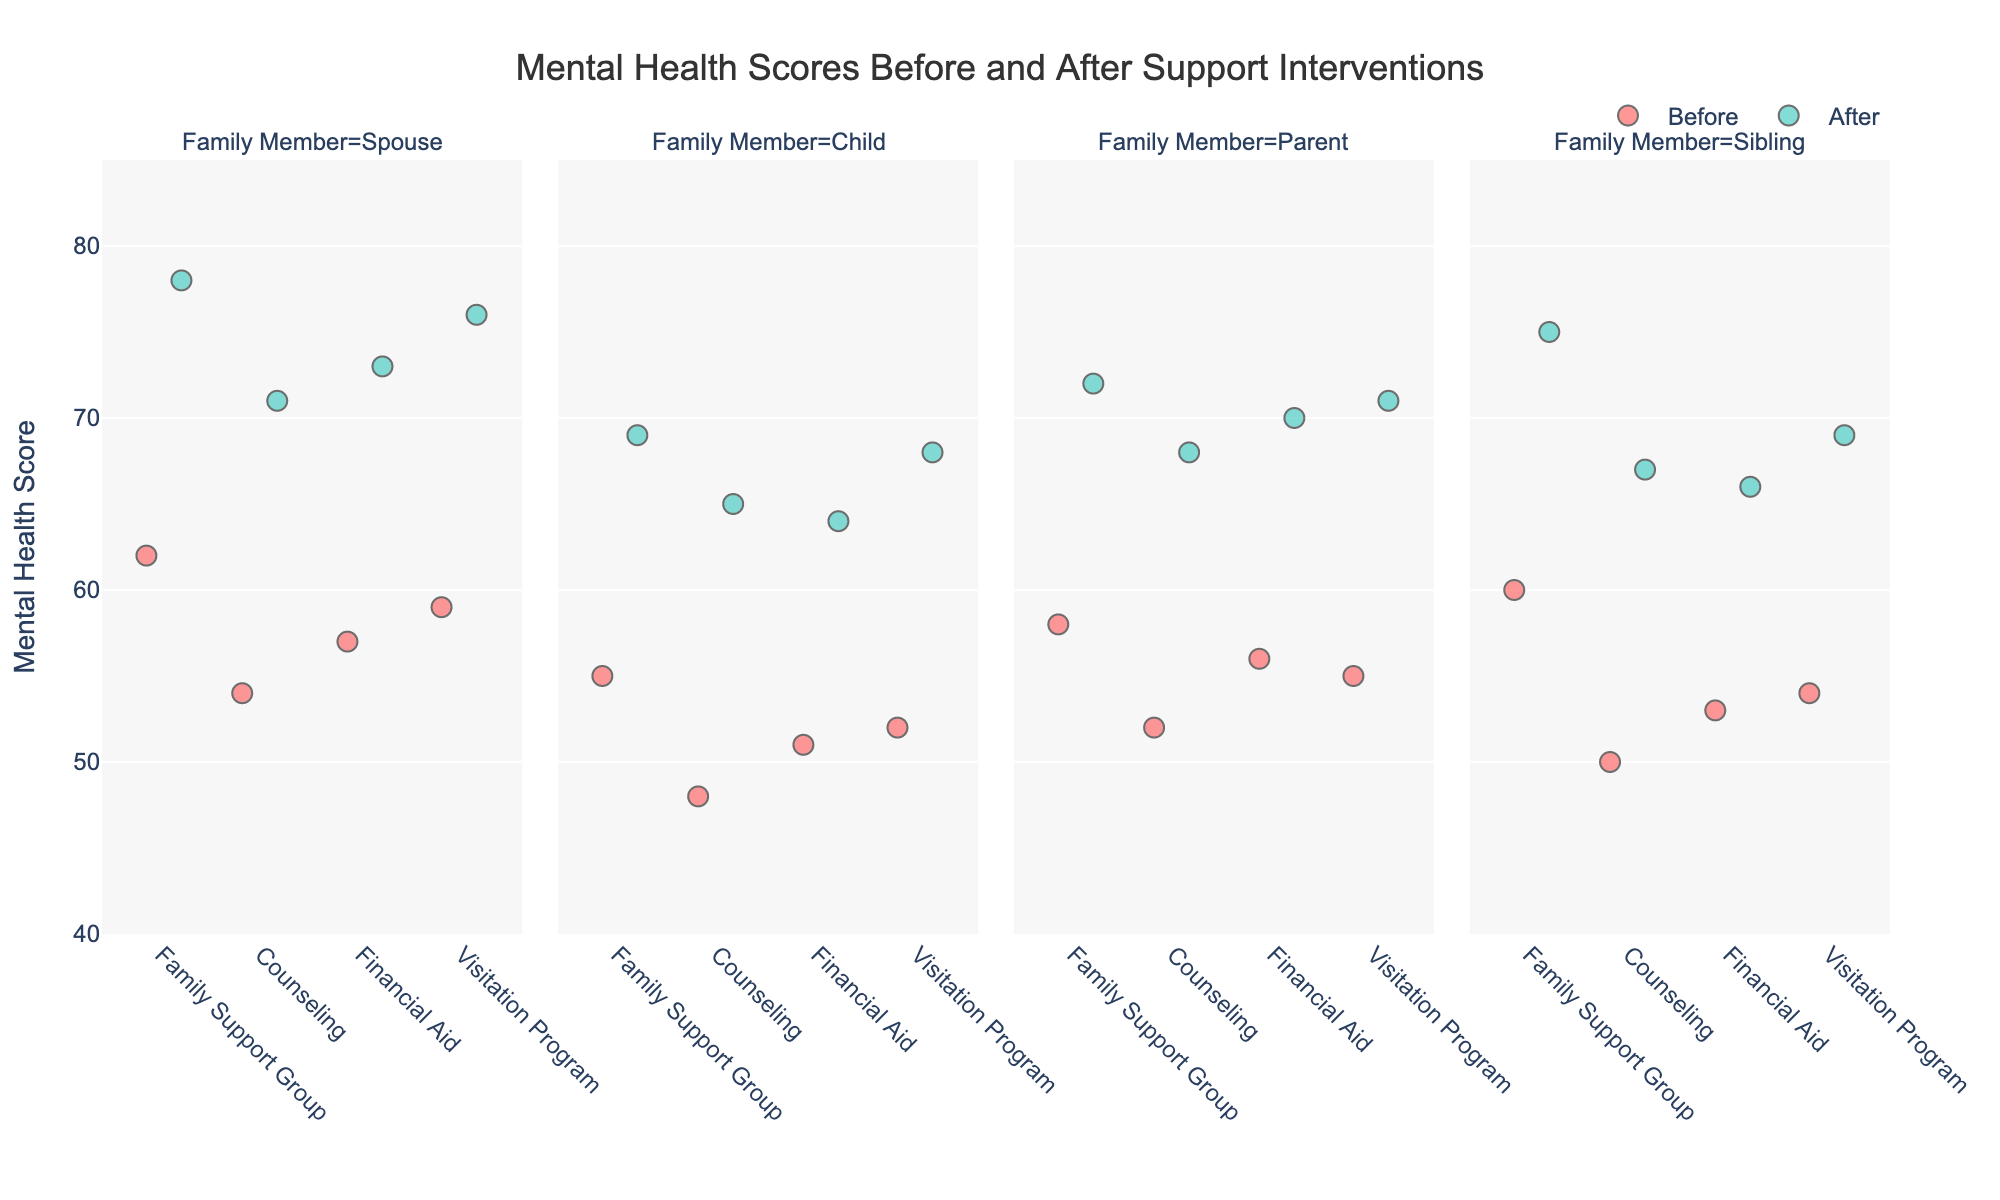What is the title of the figure? The title is found at the top center of the figure and provides a summary of what the figure represents.
Answer: Mental Health Scores Before and After Support Interventions What are the colors used to represent the mental health scores before and after the interventions? Look for the legend in the figure, which usually indicates the colors representing different categories.
Answer: Red for Before, Green for After Which intervention shows the highest improvement in mental health score for the 'Spouse' family member? Observe the position of the 'After' data points for the 'Spouse' across all interventions and compare their improvement from 'Before'.
Answer: Visitation Program What is the approximate range of mental health scores on the y-axis? Look at the minimum and maximum values indicated on the y-axis ticks.
Answer: 40 to 85 How many types of interventions are plotted on the x-axis? Count the number of distinct categories on the x-axis.
Answer: 4 For which family member category do all interventions show an improvement in mental health scores? Check each 'Before' and 'After' data point for each intervention across all family members and see if all show improvements.
Answer: All family members What is the visual pattern of mental health scores 'Before' and 'After' for the 'Sibling' category? Evaluate the position and spread of 'Before' and 'After' data points specifically for the 'Sibling' facet.
Answer: All scores show improvement after interventions with a similar spread Which family member shows the least variation in mental health score improvement across different interventions? Compare the 'Before' and 'After' improvements for each family member and check for smallest variation.
Answer: Spouse Compare the overall mental health score improvement for 'Counseling' versus 'Financial Aid'. Assess the improvements ('Before' to 'After') for both 'Counseling' and 'Financial Aid' interventions and compare their overall change.
Answer: Financial Aid shows slightly higher improvements What pattern do you notice about the mental health scores in the 'Child' category after interventions compared to before interventions? Look specifically at the 'Child' category and observe where 'Before' and 'After' scores are positioned; compare their spreads and central tendencies.
Answer: Scores after interventions are consistently higher across all types of interventions 